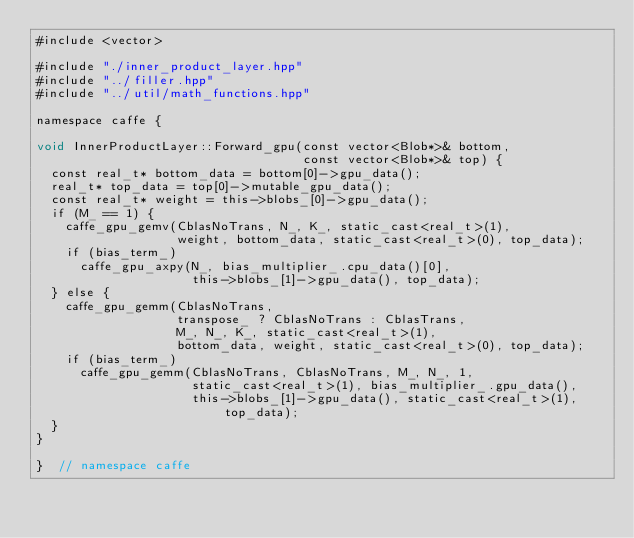<code> <loc_0><loc_0><loc_500><loc_500><_Cuda_>#include <vector>

#include "./inner_product_layer.hpp"
#include "../filler.hpp"
#include "../util/math_functions.hpp"

namespace caffe {

void InnerProductLayer::Forward_gpu(const vector<Blob*>& bottom,
                                    const vector<Blob*>& top) {
  const real_t* bottom_data = bottom[0]->gpu_data();
  real_t* top_data = top[0]->mutable_gpu_data();
  const real_t* weight = this->blobs_[0]->gpu_data();
  if (M_ == 1) {
    caffe_gpu_gemv(CblasNoTrans, N_, K_, static_cast<real_t>(1),
                   weight, bottom_data, static_cast<real_t>(0), top_data);
    if (bias_term_)
      caffe_gpu_axpy(N_, bias_multiplier_.cpu_data()[0],
                     this->blobs_[1]->gpu_data(), top_data);
  } else {
    caffe_gpu_gemm(CblasNoTrans,
                   transpose_ ? CblasNoTrans : CblasTrans,
                   M_, N_, K_, static_cast<real_t>(1),
                   bottom_data, weight, static_cast<real_t>(0), top_data);
    if (bias_term_)
      caffe_gpu_gemm(CblasNoTrans, CblasNoTrans, M_, N_, 1,
                     static_cast<real_t>(1), bias_multiplier_.gpu_data(),
                     this->blobs_[1]->gpu_data(), static_cast<real_t>(1), top_data);
  }
}

}  // namespace caffe
</code> 